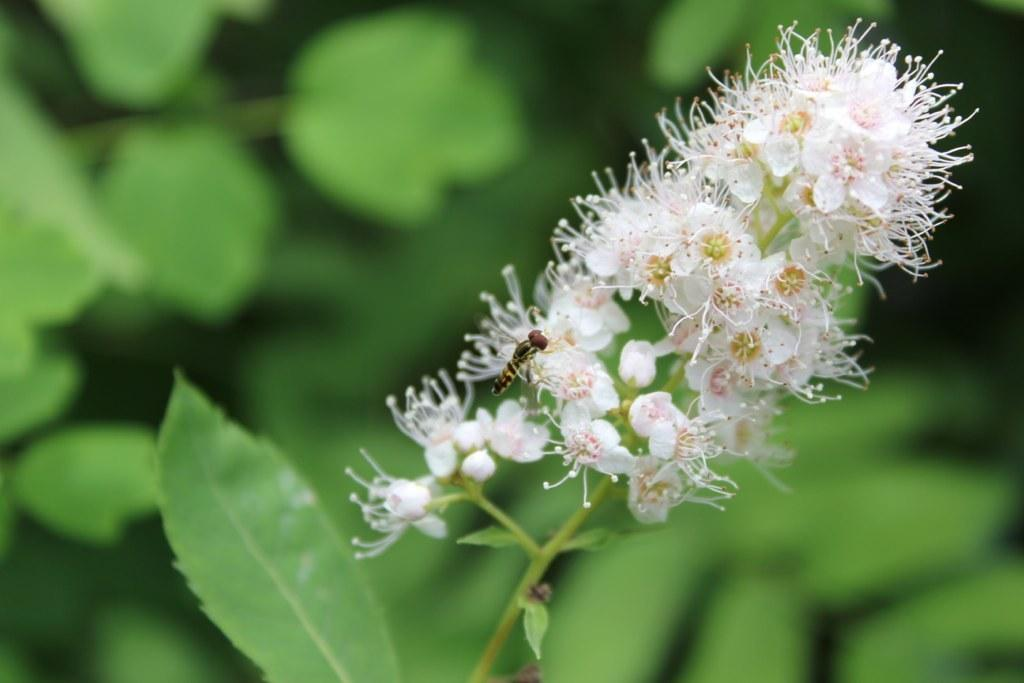What type of flowers can be seen in the image? There are tiny flowers in the image. What color are the flowers? The flowers are white in color. Is there anything sitting on the flowers? Yes, there is an insect sitting on the flowers. What else can be seen in the image besides the flowers and insect? The flower stem and leaves are present in the image. Who is the manager of the insurance company in the image? There is no reference to an insurance company or a manager in the image, as it features tiny white flowers with an insect sitting on them. 